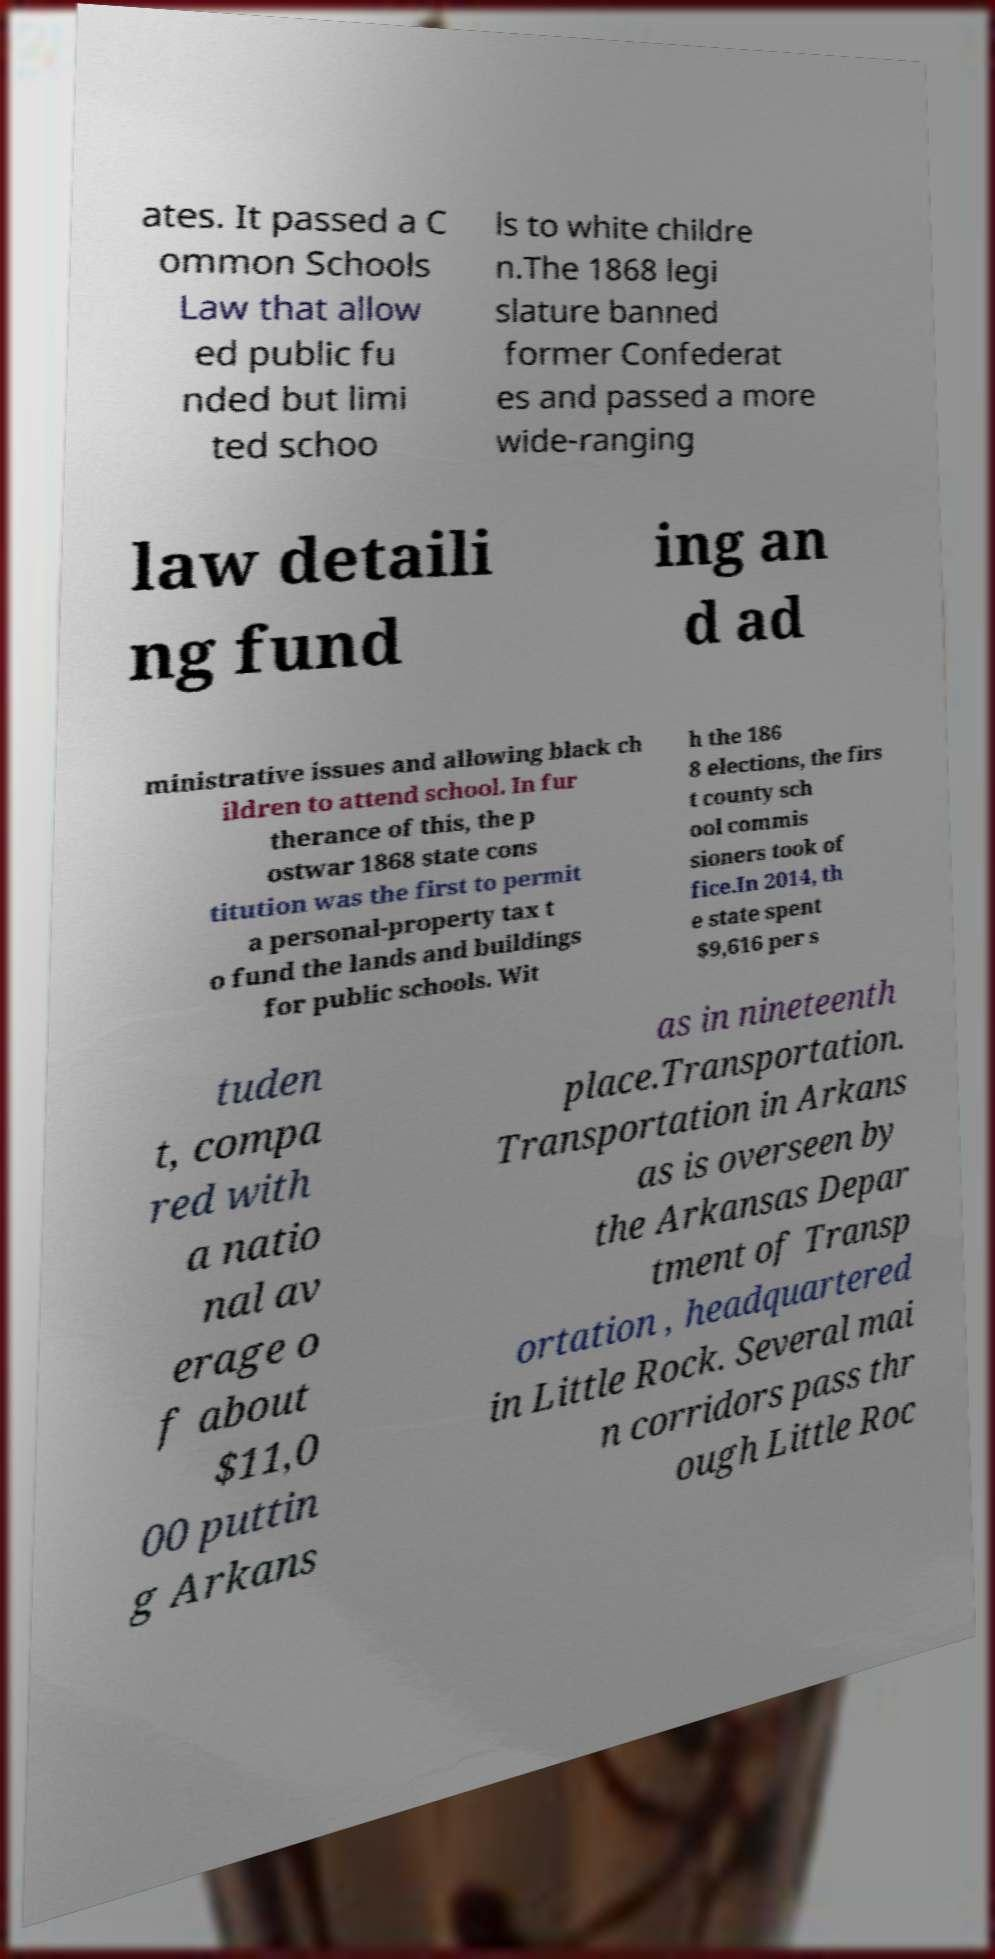Could you extract and type out the text from this image? ates. It passed a C ommon Schools Law that allow ed public fu nded but limi ted schoo ls to white childre n.The 1868 legi slature banned former Confederat es and passed a more wide-ranging law detaili ng fund ing an d ad ministrative issues and allowing black ch ildren to attend school. In fur therance of this, the p ostwar 1868 state cons titution was the first to permit a personal-property tax t o fund the lands and buildings for public schools. Wit h the 186 8 elections, the firs t county sch ool commis sioners took of fice.In 2014, th e state spent $9,616 per s tuden t, compa red with a natio nal av erage o f about $11,0 00 puttin g Arkans as in nineteenth place.Transportation. Transportation in Arkans as is overseen by the Arkansas Depar tment of Transp ortation , headquartered in Little Rock. Several mai n corridors pass thr ough Little Roc 